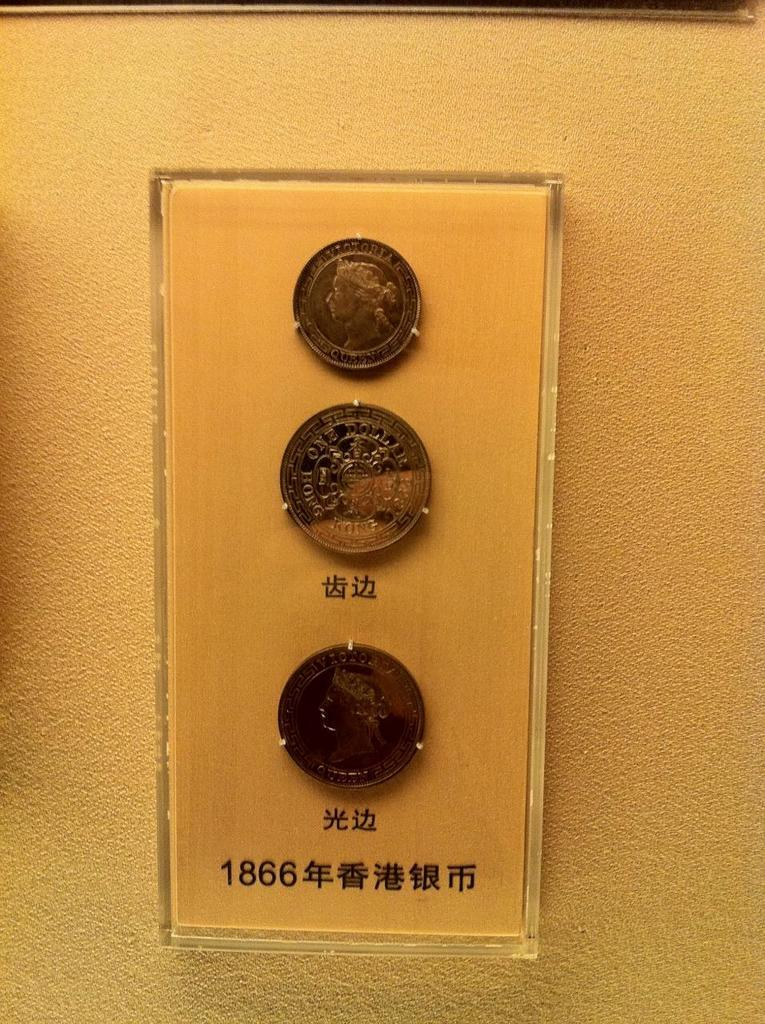<image>
Provide a brief description of the given image. Three coins from Hong Kong with the sign 1866 are displayed in a plastic case. 